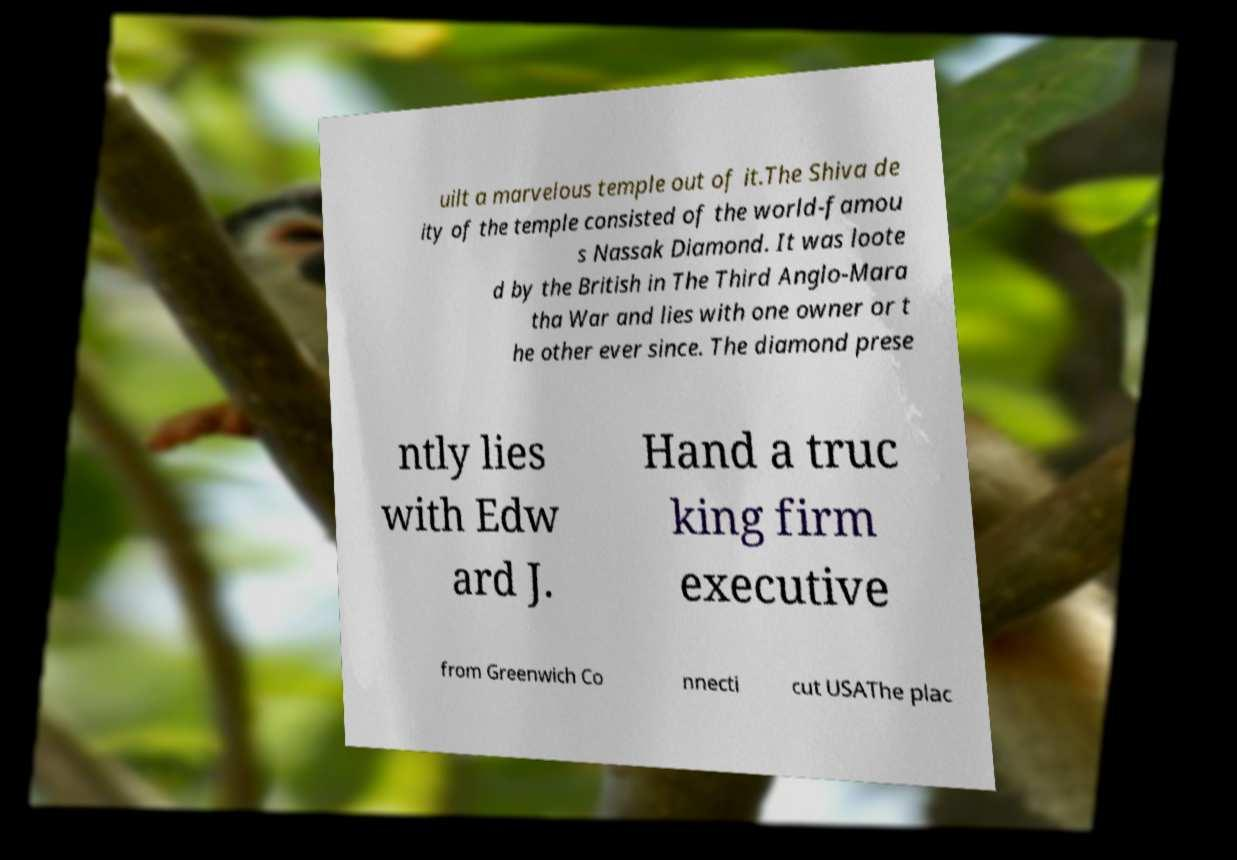Could you assist in decoding the text presented in this image and type it out clearly? uilt a marvelous temple out of it.The Shiva de ity of the temple consisted of the world-famou s Nassak Diamond. It was loote d by the British in The Third Anglo-Mara tha War and lies with one owner or t he other ever since. The diamond prese ntly lies with Edw ard J. Hand a truc king firm executive from Greenwich Co nnecti cut USAThe plac 